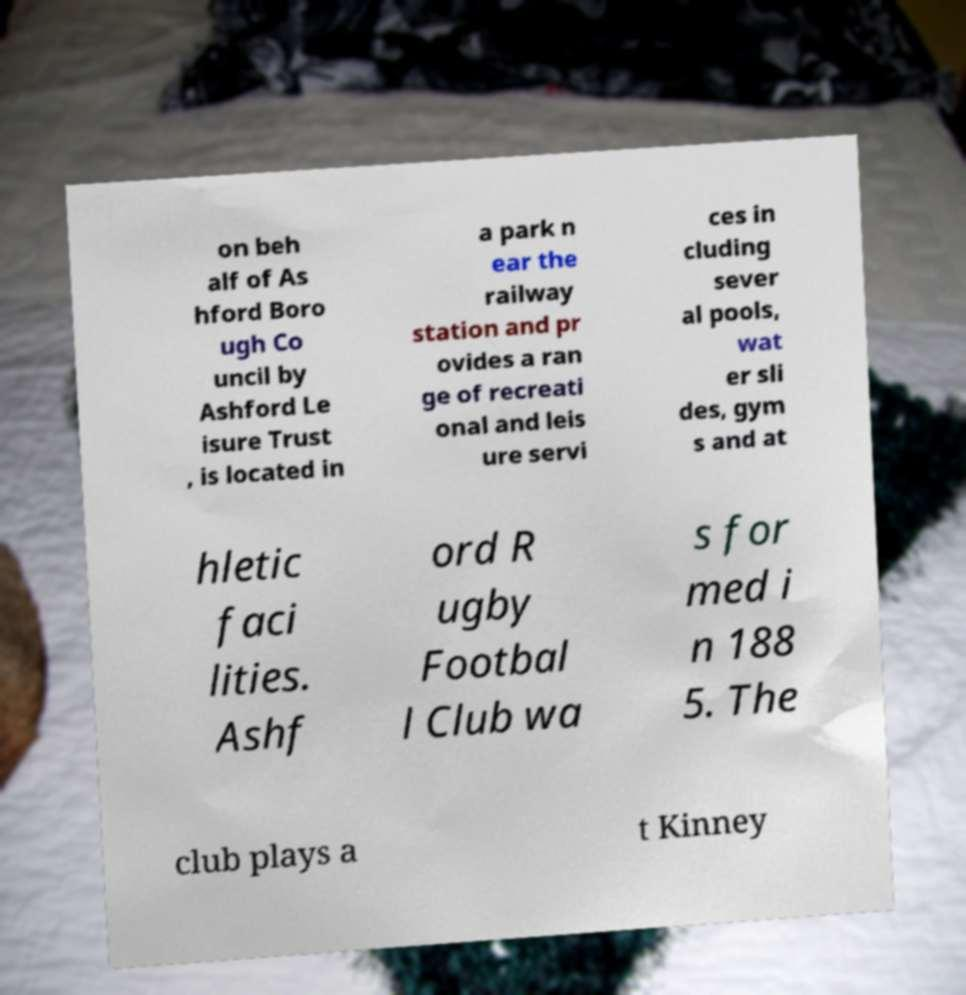What messages or text are displayed in this image? I need them in a readable, typed format. on beh alf of As hford Boro ugh Co uncil by Ashford Le isure Trust , is located in a park n ear the railway station and pr ovides a ran ge of recreati onal and leis ure servi ces in cluding sever al pools, wat er sli des, gym s and at hletic faci lities. Ashf ord R ugby Footbal l Club wa s for med i n 188 5. The club plays a t Kinney 